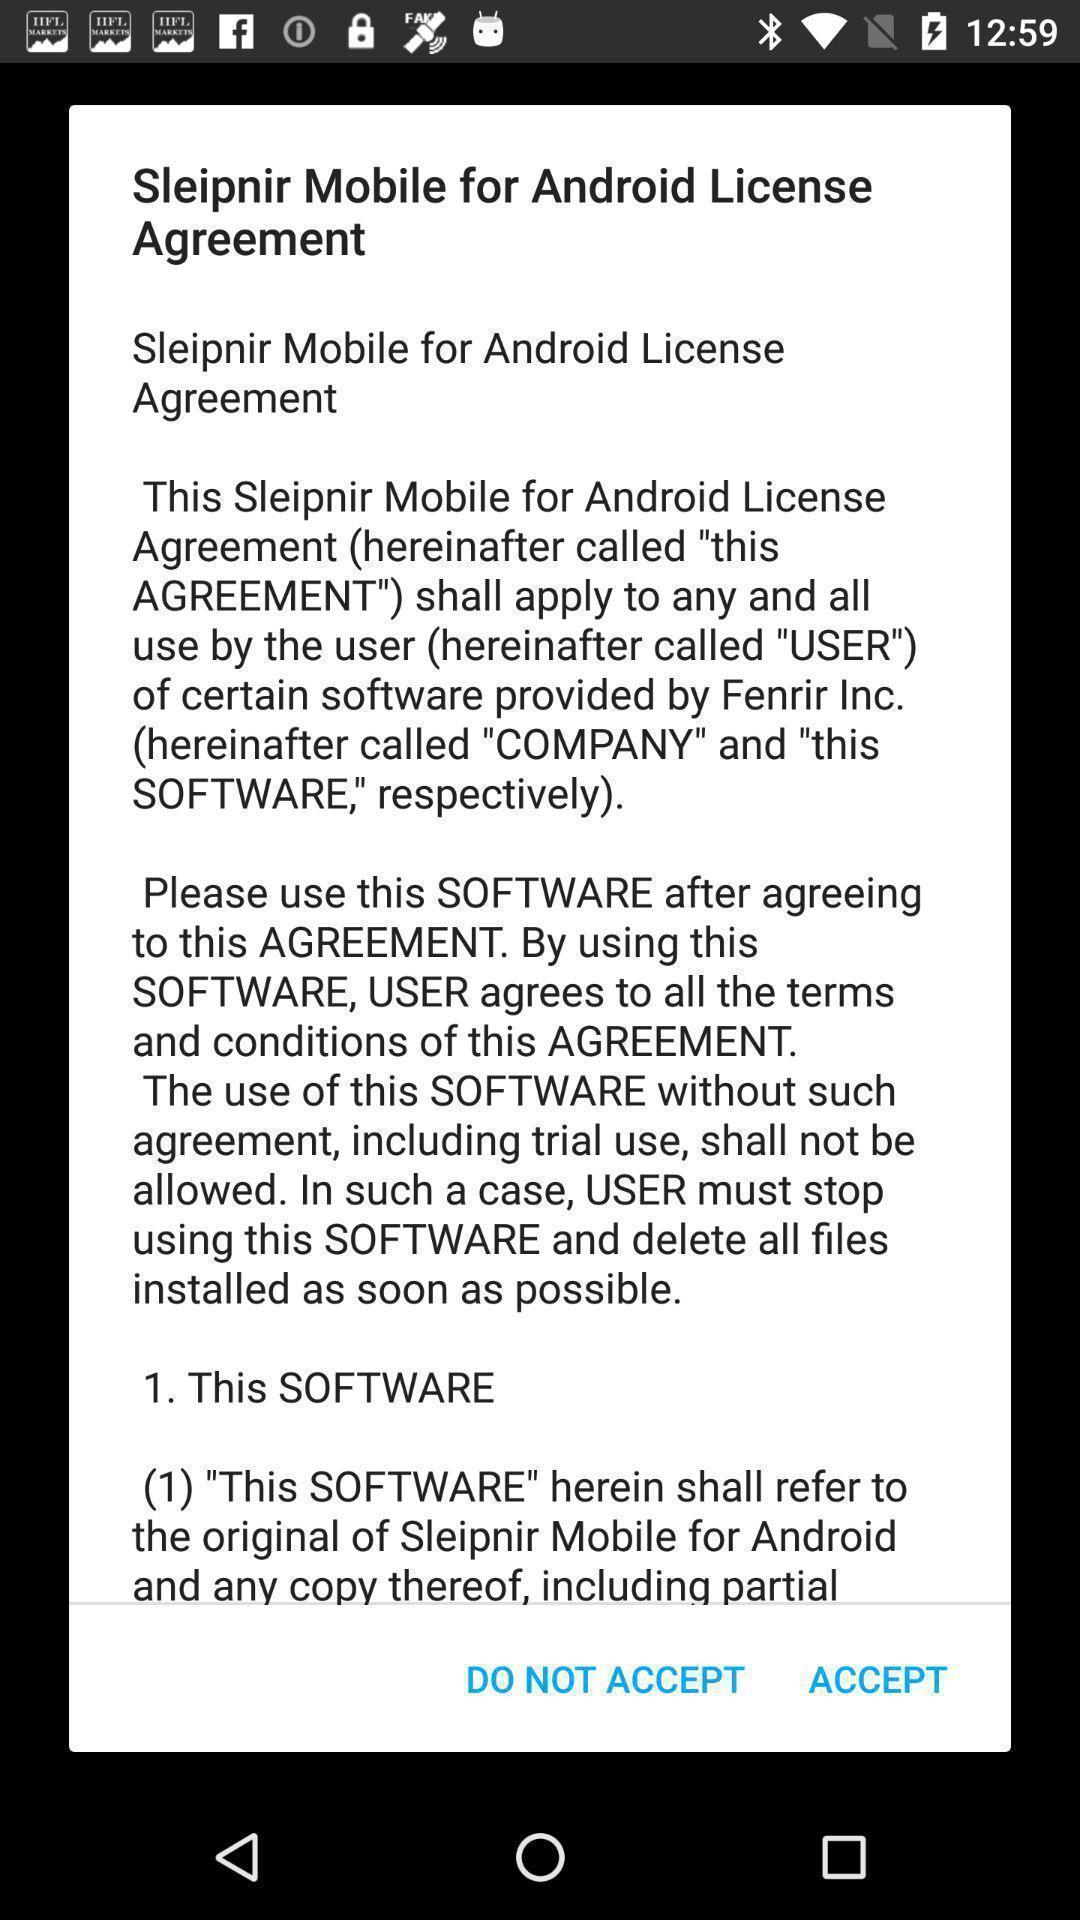Provide a detailed account of this screenshot. Popup displaying policy condition information. 